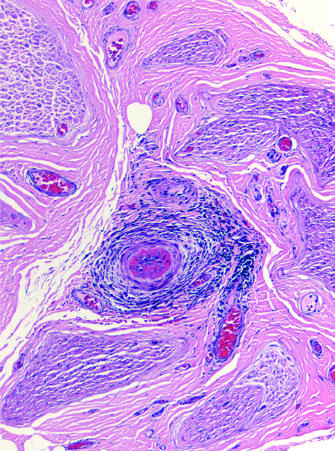does the blue area contain an inflammatory infiltrate around small blood vessels that has obliterated a vessel in b?
Answer the question using a single word or phrase. No 